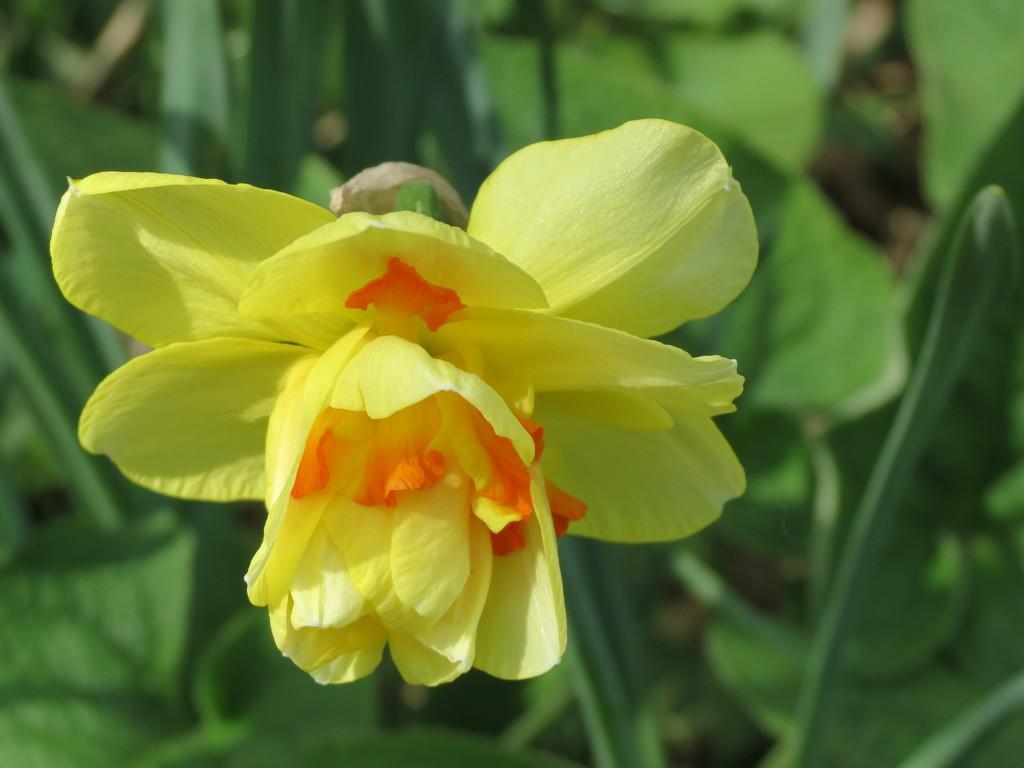In one or two sentences, can you explain what this image depicts? In the center of this picture we can see a yellow color flower and in the background we can see the green leaves and some other objects. 